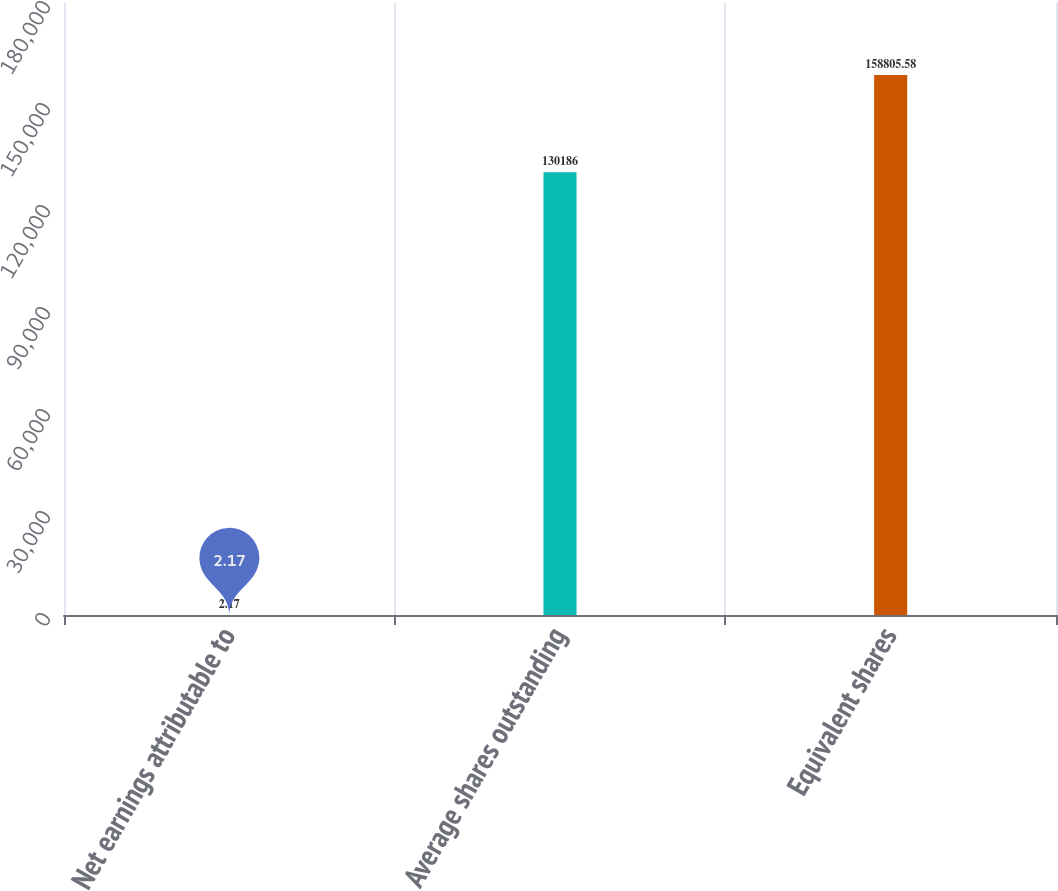Convert chart. <chart><loc_0><loc_0><loc_500><loc_500><bar_chart><fcel>Net earnings attributable to<fcel>Average shares outstanding<fcel>Equivalent shares<nl><fcel>2.17<fcel>130186<fcel>158806<nl></chart> 